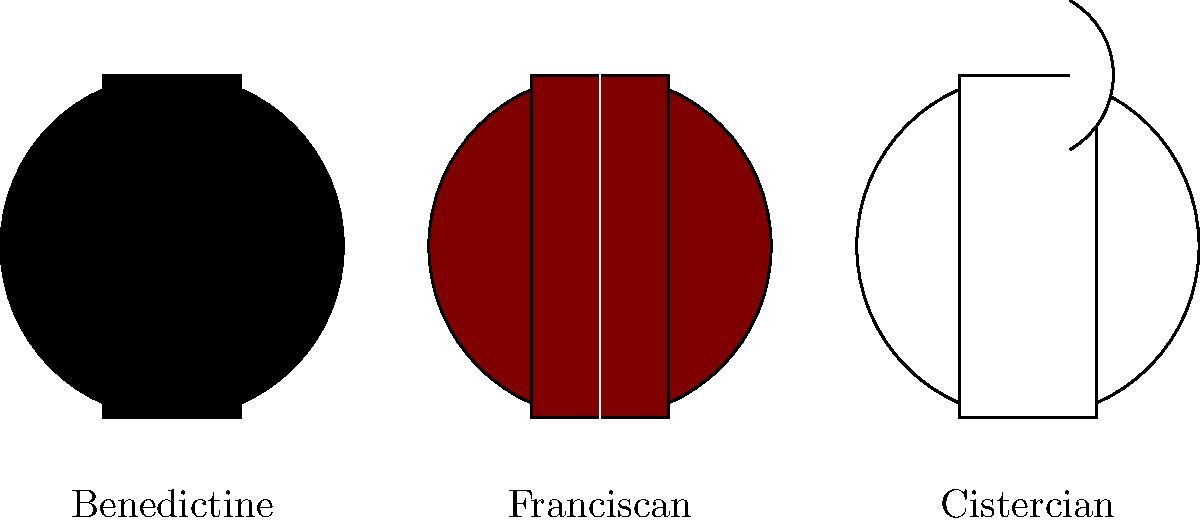Which of the monastic habits depicted is associated with the order known for its white robes and is often referred to as the "White Monks"? To answer this question, let's analyze the three monastic habits shown in the image:

1. Benedictine habit (left):
   - Black in color
   - Features a long scapular

2. Franciscan habit (center):
   - Brown in color
   - Features a long scapular with a white cord

3. Cistercian habit (right):
   - White in color
   - Features a long scapular and a distinctive cowl

The question asks about an order known for its white robes and referred to as the "White Monks." Among the three habits shown, only the Cistercian habit is white.

Historically, the Cistercian Order, a reformed branch of the Benedictine Order, is indeed known as the "White Monks" due to their distinctive white habits. This contrasts with the Benedictines, who are sometimes called the "Black Monks" because of their black habits.

The white color of the Cistercian habit symbolizes purity and simplicity, reflecting the order's emphasis on a strict interpretation of the Rule of St. Benedict and a return to a more austere monastic life.

Therefore, the correct answer is the Cistercian habit, which is depicted on the right side of the image.
Answer: Cistercian 